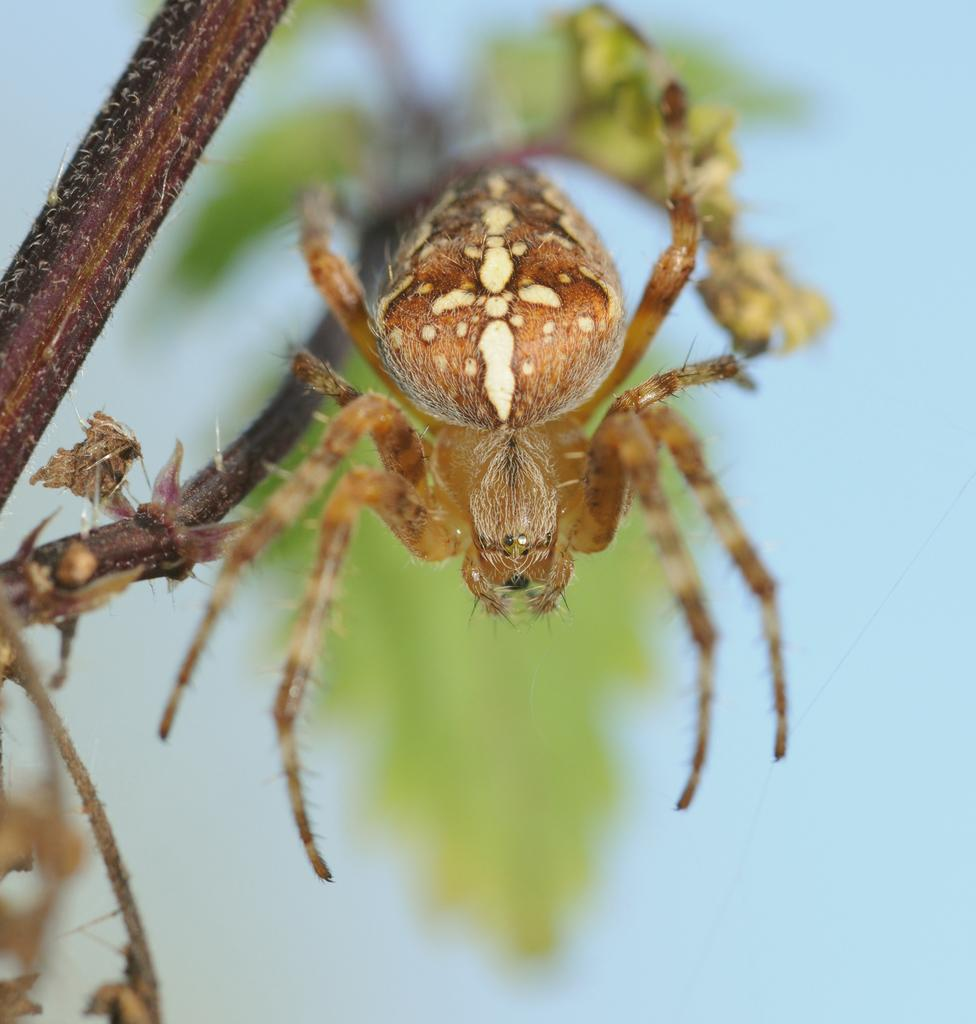What is the main subject of the image? There is a spider in the image. Where is the spider located? The spider is on a stem. Can you describe the background of the image? The background of the image appears blurry. What type of clam is visible in the image? There is no clam present in the image; it features a spider on a stem. What advice does the spider give in the image? There is no indication in the image that the spider is giving any advice, as it is a still image and not a conversation. 